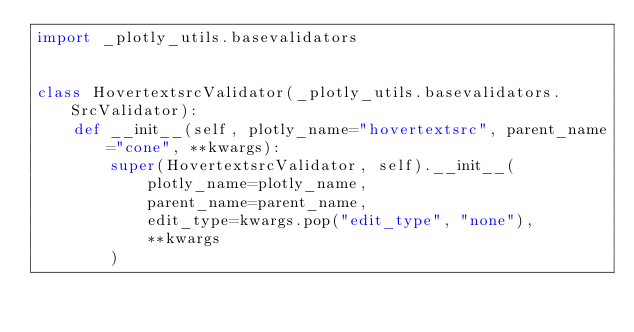Convert code to text. <code><loc_0><loc_0><loc_500><loc_500><_Python_>import _plotly_utils.basevalidators


class HovertextsrcValidator(_plotly_utils.basevalidators.SrcValidator):
    def __init__(self, plotly_name="hovertextsrc", parent_name="cone", **kwargs):
        super(HovertextsrcValidator, self).__init__(
            plotly_name=plotly_name,
            parent_name=parent_name,
            edit_type=kwargs.pop("edit_type", "none"),
            **kwargs
        )
</code> 